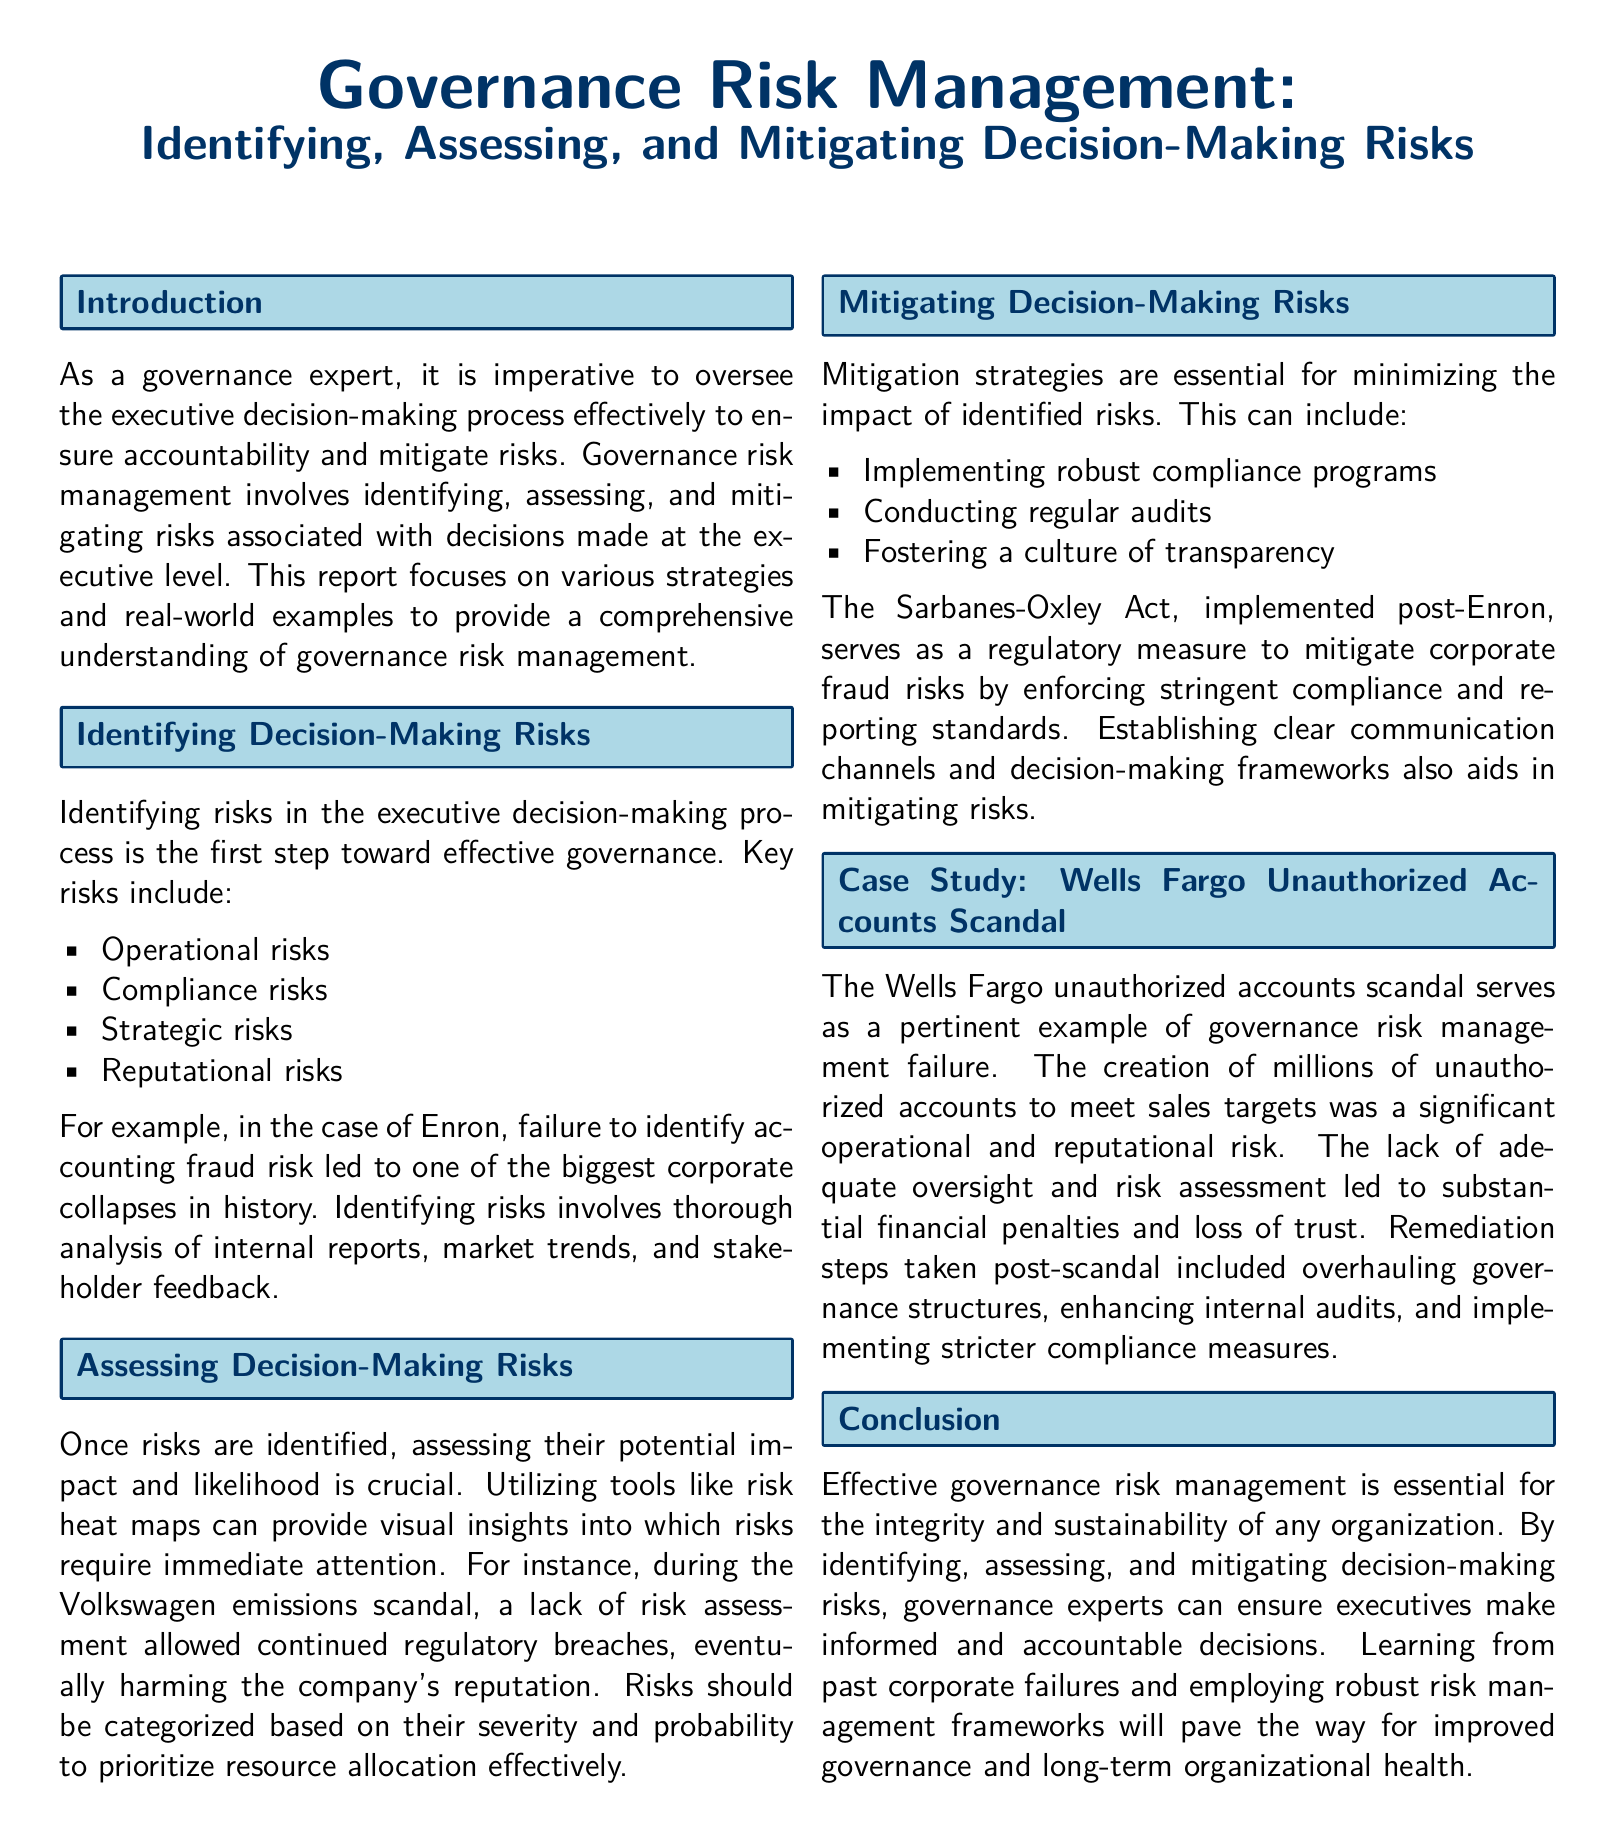What are the key risks mentioned? The key risks identified in the document include operational, compliance, strategic, and reputational risks.
Answer: Operational, compliance, strategic, reputational What scandal is provided as a case study? The document details the Wells Fargo unauthorized accounts scandal as a significant example of governance risk management failure.
Answer: Wells Fargo unauthorized accounts scandal Which act was implemented post-Enron? The Sarbanes-Oxley Act was put in place to address corporate fraud risks after the Enron scandal.
Answer: Sarbanes-Oxley Act What is the primary focus of the report? The report focuses on identifying, assessing, and mitigating risks associated with executive decision-making.
Answer: Governance risk management What tool is mentioned for assessing risks? The document references the use of risk heat maps as a tool to assess the potential impact and likelihood of risks.
Answer: Risk heat maps Which company faced issues due to a lack of risk assessment? Volkswagen faced significant problems due to a lack of risk assessment leading to regulatory breaches.
Answer: Volkswagen How many unauthorized accounts were created in the Wells Fargo scandal? While the document does not specify an exact number, millions of unauthorized accounts were created.
Answer: Millions What is the aim of governance risk management? The aim is to ensure accountability and minimize the risks associated with executive decision-making processes.
Answer: Ensure accountability What remediation steps were taken after the Wells Fargo scandal? Post-scandal remediation steps included overhauling governance structures, enhancing internal audits, and implementing stricter compliance measures.
Answer: Overhauling governance structures, enhancing internal audits, implementing stricter compliance measures 